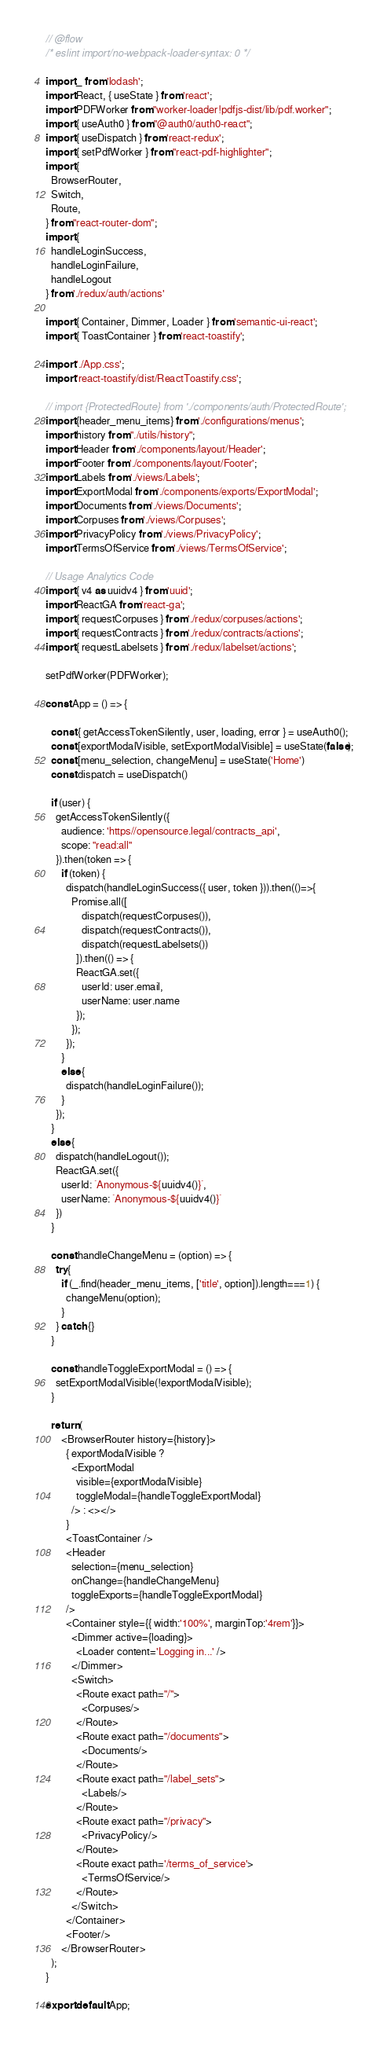Convert code to text. <code><loc_0><loc_0><loc_500><loc_500><_JavaScript_>// @flow
/* eslint import/no-webpack-loader-syntax: 0 */

import _ from 'lodash';
import React, { useState } from 'react';
import PDFWorker from "worker-loader!pdfjs-dist/lib/pdf.worker";
import { useAuth0 } from "@auth0/auth0-react";
import { useDispatch } from 'react-redux';
import { setPdfWorker } from "react-pdf-highlighter";
import {
  BrowserRouter,
  Switch,
  Route,
} from "react-router-dom";
import {
  handleLoginSuccess,
  handleLoginFailure,
  handleLogout
} from './redux/auth/actions'

import { Container, Dimmer, Loader } from 'semantic-ui-react';
import { ToastContainer } from 'react-toastify';

import './App.css';
import 'react-toastify/dist/ReactToastify.css';

// import {ProtectedRoute} from './components/auth/ProtectedRoute';
import {header_menu_items} from './configurations/menus';
import history from "./utils/history";
import Header from './components/layout/Header';
import Footer from './components/layout/Footer';
import Labels from './views/Labels';
import ExportModal from './components/exports/ExportModal';
import Documents from './views/Documents';
import Corpuses from './views/Corpuses';
import PrivacyPolicy from './views/PrivacyPolicy';
import TermsOfService from './views/TermsOfService';

// Usage Analytics Code
import { v4 as uuidv4 } from 'uuid';
import ReactGA from 'react-ga';
import { requestCorpuses } from './redux/corpuses/actions';
import { requestContracts } from './redux/contracts/actions';
import { requestLabelsets } from './redux/labelset/actions';

setPdfWorker(PDFWorker);

const App = () => {

  const { getAccessTokenSilently, user, loading, error } = useAuth0();
  const [exportModalVisible, setExportModalVisible] = useState(false);
  const [menu_selection, changeMenu] = useState('Home')
  const dispatch = useDispatch()
  
  if (user) {
    getAccessTokenSilently({
      audience: 'https//opensource.legal/contracts_api',
      scope: "read:all"
    }).then(token => {
      if (token) {
        dispatch(handleLoginSuccess({ user, token })).then(()=>{
          Promise.all([
              dispatch(requestCorpuses()),
              dispatch(requestContracts()),
              dispatch(requestLabelsets())
            ]).then(() => {
            ReactGA.set({
              userId: user.email,
              userName: user.name
            });
          });
        });
      }
      else {
        dispatch(handleLoginFailure());
      }
    });
  }
  else {
    dispatch(handleLogout());
    ReactGA.set({
      userId: `Anonymous-${uuidv4()}`,
      userName: `Anonymous-${uuidv4()}`
    })
  }

  const handleChangeMenu = (option) => {
    try{
      if (_.find(header_menu_items, ['title', option]).length===1) {
        changeMenu(option);
      }
    } catch {}
  }

  const handleToggleExportModal = () => {
    setExportModalVisible(!exportModalVisible);
  }

  return (
      <BrowserRouter history={history}>
        { exportModalVisible ? 
          <ExportModal
            visible={exportModalVisible}
            toggleModal={handleToggleExportModal}
          /> : <></> 
        }
        <ToastContainer />
        <Header 
          selection={menu_selection}
          onChange={handleChangeMenu}
          toggleExports={handleToggleExportModal}
        />
        <Container style={{ width:'100%', marginTop:'4rem'}}>
          <Dimmer active={loading}>
            <Loader content='Logging in...' />
          </Dimmer>
          <Switch>
            <Route exact path="/">
              <Corpuses/>
            </Route>
            <Route exact path="/documents">
              <Documents/>
            </Route>
            <Route exact path="/label_sets">
              <Labels/>
            </Route>
            <Route exact path="/privacy">
              <PrivacyPolicy/>
            </Route>
            <Route exact path='/terms_of_service'>
              <TermsOfService/>
            </Route>
          </Switch>
        </Container>
        <Footer/>
      </BrowserRouter>
  );
}

export default App;</code> 